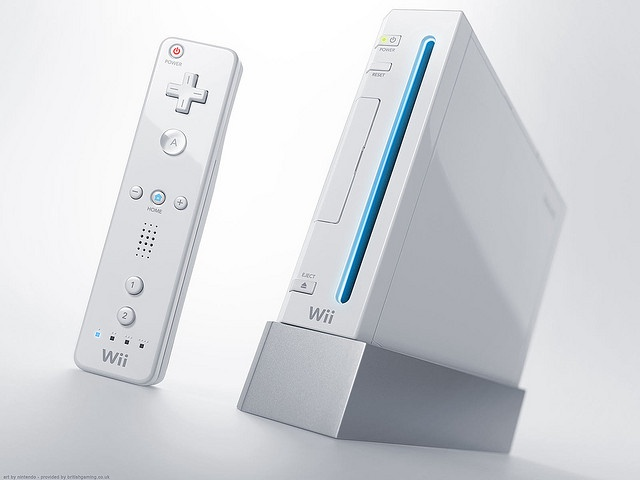Describe the objects in this image and their specific colors. I can see a remote in white, lightgray, and darkgray tones in this image. 